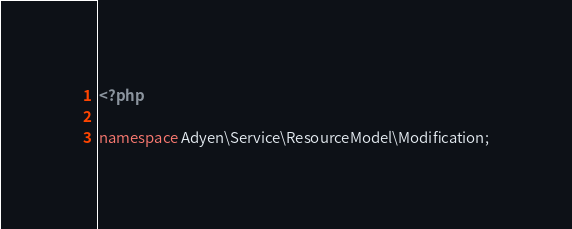<code> <loc_0><loc_0><loc_500><loc_500><_PHP_><?php

namespace Adyen\Service\ResourceModel\Modification;
</code> 